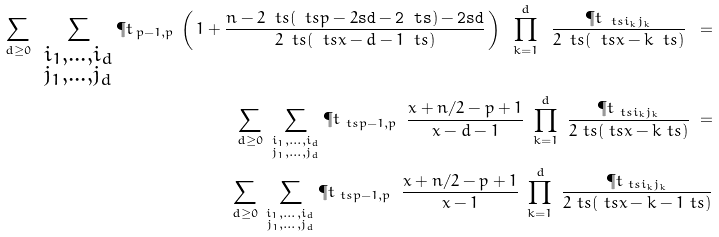<formula> <loc_0><loc_0><loc_500><loc_500>\sum _ { d \geq 0 } \ \sum _ { \substack { i _ { 1 } , \dots , i _ { d } \\ j _ { 1 } , \dots , j _ { d } } } \P t _ { \, p - 1 , p } \, \left ( \, 1 + \frac { n - 2 \ t s ( \ t s p - 2 \tt s d - 2 \ t s ) - 2 \tt s d } { 2 \ t s ( \ t s x - d - 1 \ t s ) } \, \right ) \ \prod _ { k = 1 } ^ { d } \ \frac { \P t _ { \ t s i _ { k } j _ { k } } } { 2 \ t s ( \ t s x - k \ t s ) } \ = \\ \sum _ { d \geq 0 } \ \sum _ { \substack { i _ { 1 } , \dots , i _ { d } \\ j _ { 1 } , \dots , j _ { d } } } \P t _ { \ t s p - 1 , p } \, \ \frac { x + n / 2 - p + 1 } { x - d - 1 } \ \prod _ { k = 1 } ^ { d } \ \frac { \P t _ { \ t s i _ { k } j _ { k } } } { 2 \ t s ( \ t s x - k \ t s ) } \ = \\ \sum _ { d \geq 0 } \ \sum _ { \substack { i _ { 1 } , \dots , i _ { d } \\ j _ { 1 } , \dots , j _ { d } } } \P t _ { \ t s p - 1 , p } \, \ \frac { x + n / 2 - p + 1 } { x - 1 } \ \prod _ { k = 1 } ^ { d } \ \frac { \P t _ { \ t s i _ { k } j _ { k } } } { 2 \ t s ( \ t s x - k - 1 \ t s ) }</formula> 